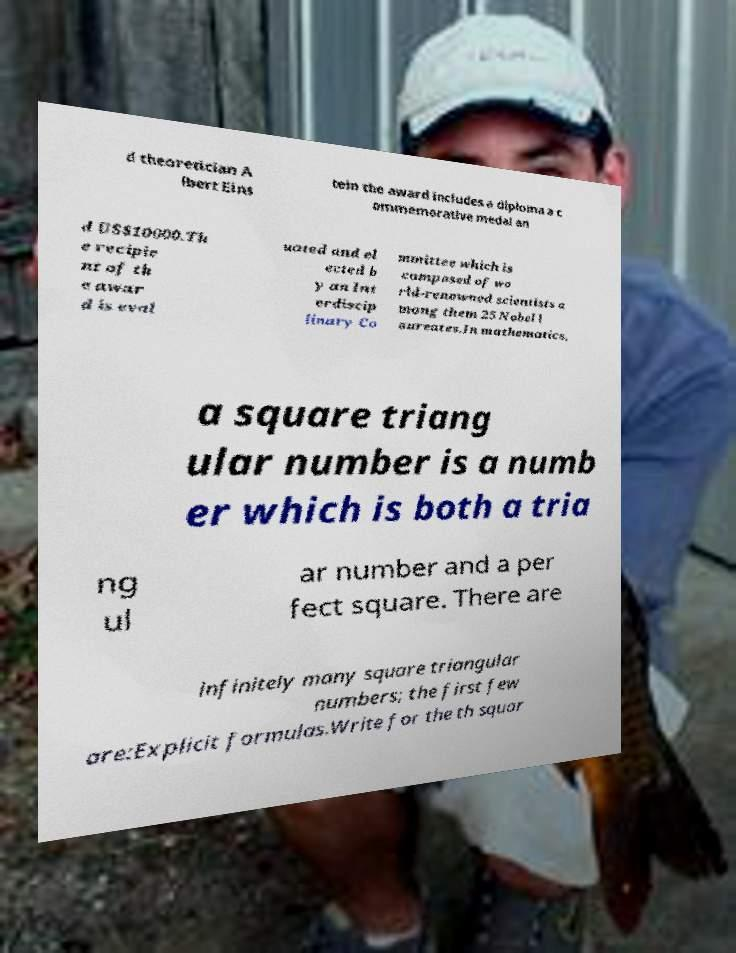I need the written content from this picture converted into text. Can you do that? d theoretician A lbert Eins tein the award includes a diploma a c ommemorative medal an d US$10000.Th e recipie nt of th e awar d is eval uated and el ected b y an Int erdiscip linary Co mmittee which is composed of wo rld-renowned scientists a mong them 25 Nobel l aureates.In mathematics, a square triang ular number is a numb er which is both a tria ng ul ar number and a per fect square. There are infinitely many square triangular numbers; the first few are:Explicit formulas.Write for the th squar 